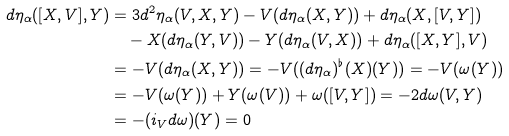Convert formula to latex. <formula><loc_0><loc_0><loc_500><loc_500>d \eta _ { \alpha } ( [ X , V ] , Y ) & = 3 d ^ { 2 } \eta _ { \alpha } ( V , X , Y ) - V ( d \eta _ { \alpha } ( X , Y ) ) + d \eta _ { \alpha } ( X , [ V , Y ] ) \\ & \quad - X ( d \eta _ { \alpha } ( Y , V ) ) - Y ( d \eta _ { \alpha } ( V , X ) ) + d \eta _ { \alpha } ( [ X , Y ] , V ) \\ & = - V ( d \eta _ { \alpha } ( X , Y ) ) = - V ( ( d \eta _ { \alpha } ) ^ { \flat } ( X ) ( Y ) ) = - V ( \omega ( Y ) ) \\ & = - V ( \omega ( Y ) ) + Y ( \omega ( V ) ) + \omega ( [ V , Y ] ) = - 2 d \omega ( V , Y ) \\ & = - ( i _ { V } d \omega ) ( Y ) = 0</formula> 